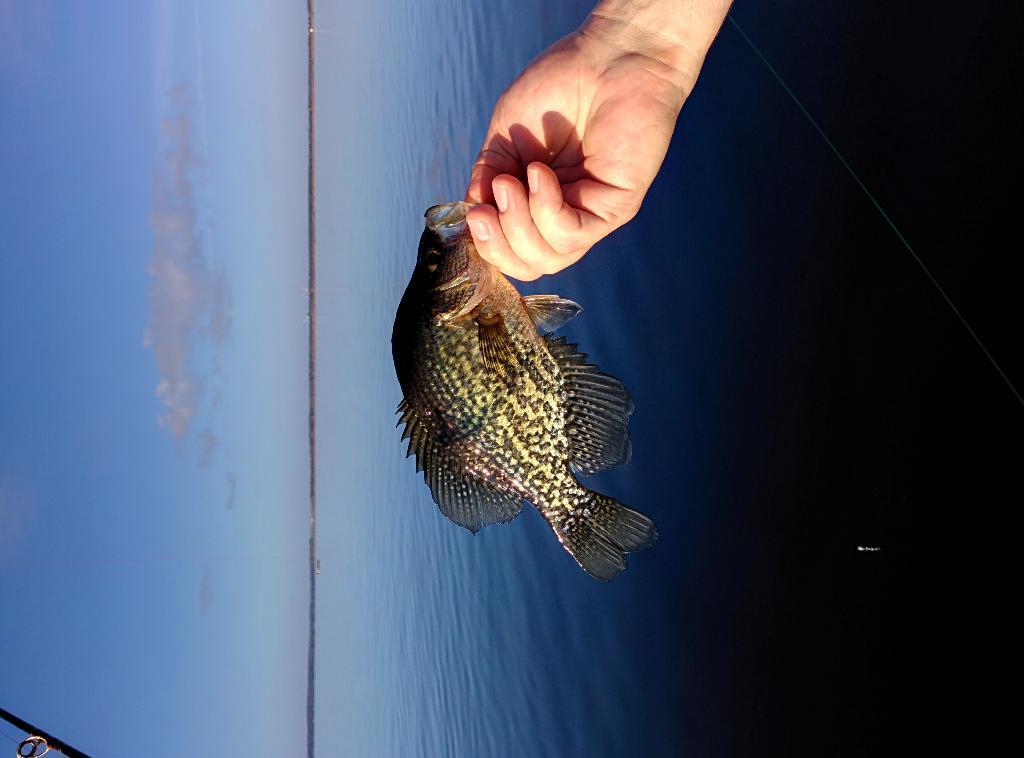How would you summarize this image in a sentence or two? This image is in left direction. In the middle of the image I can see a person's hand holding a fish. On the right side there is an ocean. On the left side, I can see the sky and clouds. 